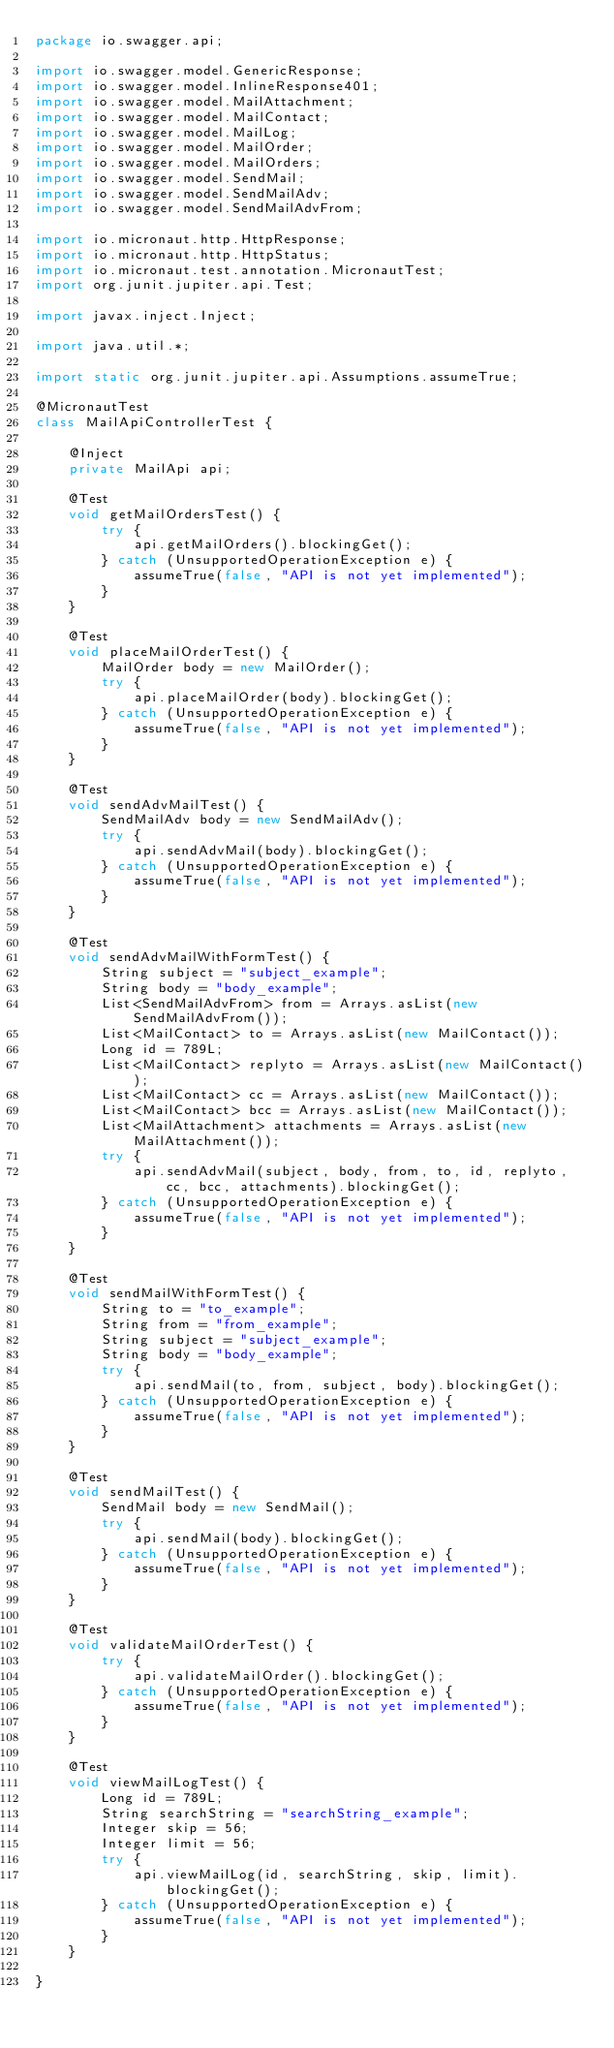Convert code to text. <code><loc_0><loc_0><loc_500><loc_500><_Java_>package io.swagger.api;

import io.swagger.model.GenericResponse;
import io.swagger.model.InlineResponse401;
import io.swagger.model.MailAttachment;
import io.swagger.model.MailContact;
import io.swagger.model.MailLog;
import io.swagger.model.MailOrder;
import io.swagger.model.MailOrders;
import io.swagger.model.SendMail;
import io.swagger.model.SendMailAdv;
import io.swagger.model.SendMailAdvFrom;

import io.micronaut.http.HttpResponse;
import io.micronaut.http.HttpStatus;
import io.micronaut.test.annotation.MicronautTest;
import org.junit.jupiter.api.Test;

import javax.inject.Inject;

import java.util.*;

import static org.junit.jupiter.api.Assumptions.assumeTrue;

@MicronautTest
class MailApiControllerTest {

    @Inject
    private MailApi api;

    @Test
    void getMailOrdersTest() {
        try {
            api.getMailOrders().blockingGet();
        } catch (UnsupportedOperationException e) {
            assumeTrue(false, "API is not yet implemented");
        }
    }

    @Test
    void placeMailOrderTest() {
        MailOrder body = new MailOrder();
        try {
            api.placeMailOrder(body).blockingGet();
        } catch (UnsupportedOperationException e) {
            assumeTrue(false, "API is not yet implemented");
        }
    }

    @Test
    void sendAdvMailTest() {
        SendMailAdv body = new SendMailAdv();
        try {
            api.sendAdvMail(body).blockingGet();
        } catch (UnsupportedOperationException e) {
            assumeTrue(false, "API is not yet implemented");
        }
    }

    @Test
    void sendAdvMailWithFormTest() {
        String subject = "subject_example";
        String body = "body_example";
        List<SendMailAdvFrom> from = Arrays.asList(new SendMailAdvFrom());
        List<MailContact> to = Arrays.asList(new MailContact());
        Long id = 789L;
        List<MailContact> replyto = Arrays.asList(new MailContact());
        List<MailContact> cc = Arrays.asList(new MailContact());
        List<MailContact> bcc = Arrays.asList(new MailContact());
        List<MailAttachment> attachments = Arrays.asList(new MailAttachment());
        try {
            api.sendAdvMail(subject, body, from, to, id, replyto, cc, bcc, attachments).blockingGet();
        } catch (UnsupportedOperationException e) {
            assumeTrue(false, "API is not yet implemented");
        }
    }

    @Test
    void sendMailWithFormTest() {
        String to = "to_example";
        String from = "from_example";
        String subject = "subject_example";
        String body = "body_example";
        try {
            api.sendMail(to, from, subject, body).blockingGet();
        } catch (UnsupportedOperationException e) {
            assumeTrue(false, "API is not yet implemented");
        }
    }

    @Test
    void sendMailTest() {
        SendMail body = new SendMail();
        try {
            api.sendMail(body).blockingGet();
        } catch (UnsupportedOperationException e) {
            assumeTrue(false, "API is not yet implemented");
        }
    }

    @Test
    void validateMailOrderTest() {
        try {
            api.validateMailOrder().blockingGet();
        } catch (UnsupportedOperationException e) {
            assumeTrue(false, "API is not yet implemented");
        }
    }

    @Test
    void viewMailLogTest() {
        Long id = 789L;
        String searchString = "searchString_example";
        Integer skip = 56;
        Integer limit = 56;
        try {
            api.viewMailLog(id, searchString, skip, limit).blockingGet();
        } catch (UnsupportedOperationException e) {
            assumeTrue(false, "API is not yet implemented");
        }
    }

}
</code> 